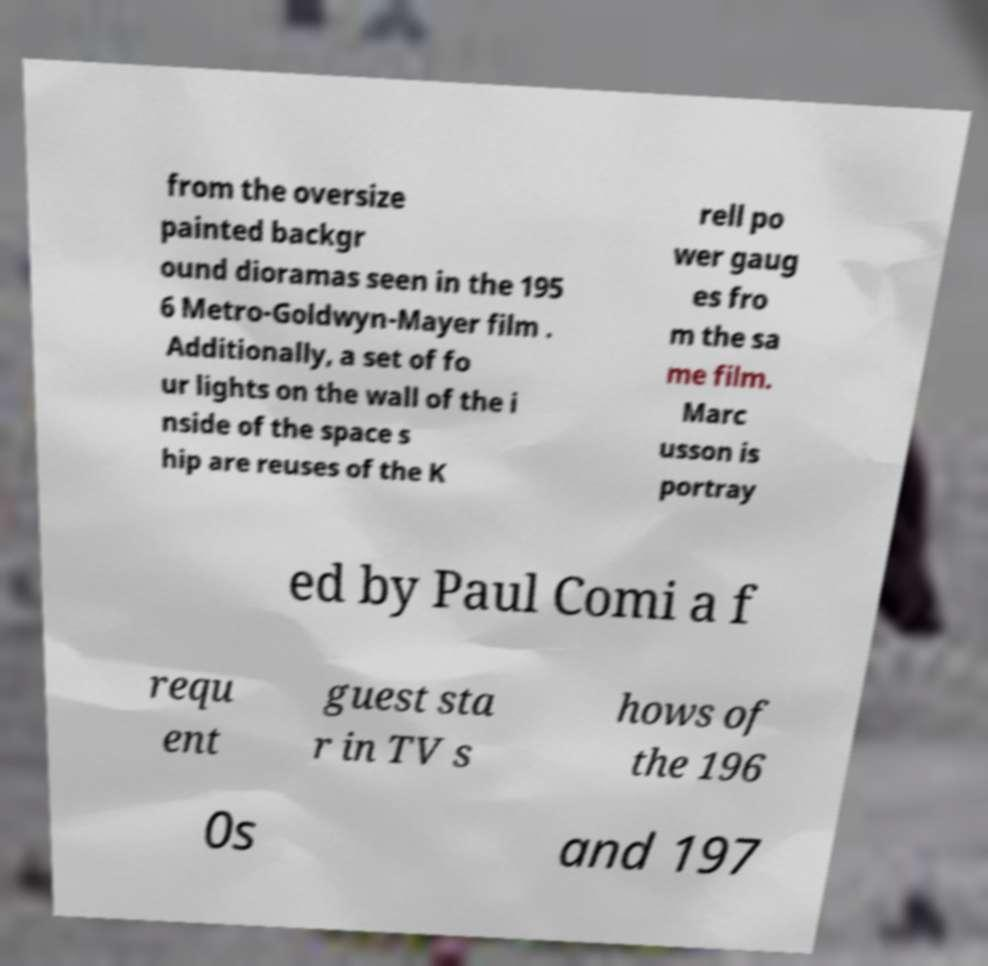Could you assist in decoding the text presented in this image and type it out clearly? from the oversize painted backgr ound dioramas seen in the 195 6 Metro-Goldwyn-Mayer film . Additionally, a set of fo ur lights on the wall of the i nside of the space s hip are reuses of the K rell po wer gaug es fro m the sa me film. Marc usson is portray ed by Paul Comi a f requ ent guest sta r in TV s hows of the 196 0s and 197 